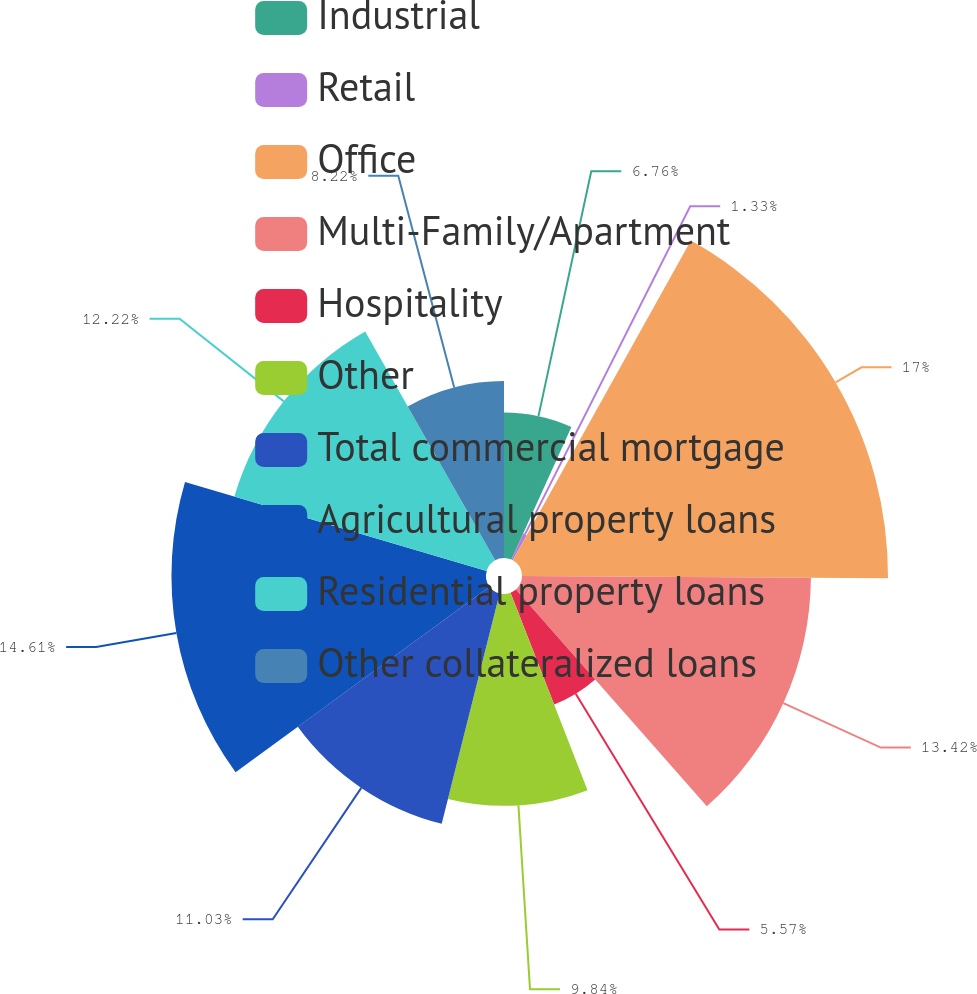Convert chart to OTSL. <chart><loc_0><loc_0><loc_500><loc_500><pie_chart><fcel>Industrial<fcel>Retail<fcel>Office<fcel>Multi-Family/Apartment<fcel>Hospitality<fcel>Other<fcel>Total commercial mortgage<fcel>Agricultural property loans<fcel>Residential property loans<fcel>Other collateralized loans<nl><fcel>6.76%<fcel>1.33%<fcel>17.0%<fcel>13.42%<fcel>5.57%<fcel>9.84%<fcel>11.03%<fcel>14.61%<fcel>12.22%<fcel>8.22%<nl></chart> 